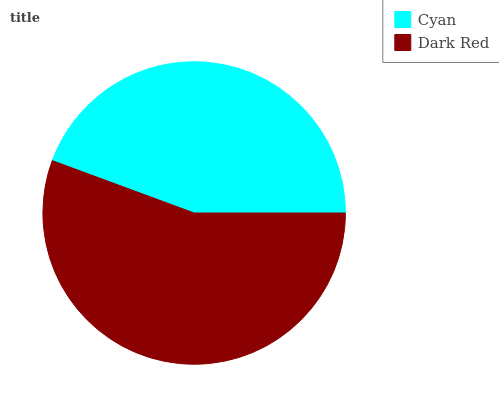Is Cyan the minimum?
Answer yes or no. Yes. Is Dark Red the maximum?
Answer yes or no. Yes. Is Dark Red the minimum?
Answer yes or no. No. Is Dark Red greater than Cyan?
Answer yes or no. Yes. Is Cyan less than Dark Red?
Answer yes or no. Yes. Is Cyan greater than Dark Red?
Answer yes or no. No. Is Dark Red less than Cyan?
Answer yes or no. No. Is Dark Red the high median?
Answer yes or no. Yes. Is Cyan the low median?
Answer yes or no. Yes. Is Cyan the high median?
Answer yes or no. No. Is Dark Red the low median?
Answer yes or no. No. 